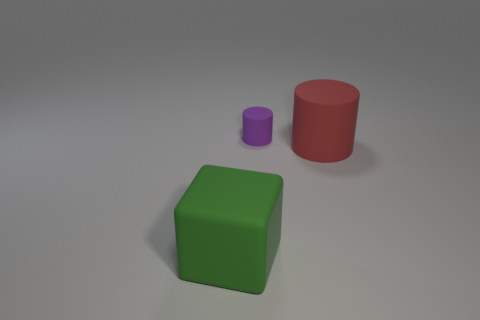Add 1 green objects. How many objects exist? 4 Subtract all cylinders. How many objects are left? 1 Subtract 0 red cubes. How many objects are left? 3 Subtract all red objects. Subtract all large cyan matte blocks. How many objects are left? 2 Add 3 large green blocks. How many large green blocks are left? 4 Add 3 small purple rubber cylinders. How many small purple rubber cylinders exist? 4 